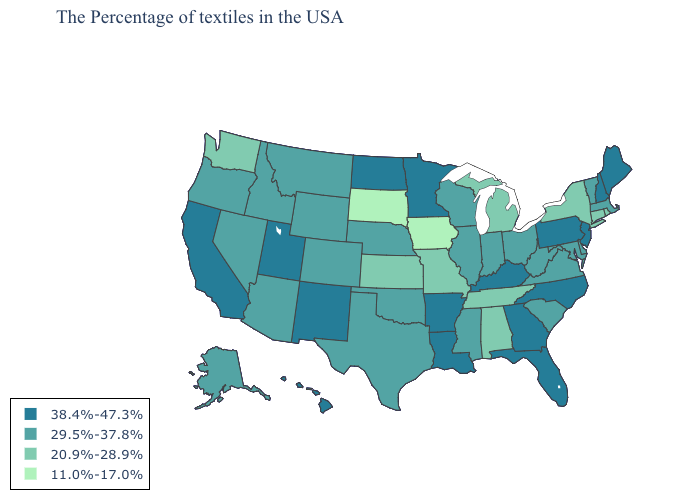Which states have the highest value in the USA?
Concise answer only. Maine, New Hampshire, New Jersey, Pennsylvania, North Carolina, Florida, Georgia, Kentucky, Louisiana, Arkansas, Minnesota, North Dakota, New Mexico, Utah, California, Hawaii. Does New York have a lower value than Michigan?
Answer briefly. No. Name the states that have a value in the range 38.4%-47.3%?
Keep it brief. Maine, New Hampshire, New Jersey, Pennsylvania, North Carolina, Florida, Georgia, Kentucky, Louisiana, Arkansas, Minnesota, North Dakota, New Mexico, Utah, California, Hawaii. Among the states that border New Hampshire , which have the lowest value?
Concise answer only. Massachusetts, Vermont. Name the states that have a value in the range 11.0%-17.0%?
Short answer required. Iowa, South Dakota. What is the value of South Dakota?
Quick response, please. 11.0%-17.0%. Is the legend a continuous bar?
Keep it brief. No. Does the map have missing data?
Give a very brief answer. No. What is the value of Vermont?
Answer briefly. 29.5%-37.8%. Does South Carolina have the highest value in the South?
Answer briefly. No. Which states have the lowest value in the West?
Concise answer only. Washington. Name the states that have a value in the range 29.5%-37.8%?
Keep it brief. Massachusetts, Vermont, Delaware, Maryland, Virginia, South Carolina, West Virginia, Ohio, Indiana, Wisconsin, Illinois, Mississippi, Nebraska, Oklahoma, Texas, Wyoming, Colorado, Montana, Arizona, Idaho, Nevada, Oregon, Alaska. What is the value of Georgia?
Quick response, please. 38.4%-47.3%. 